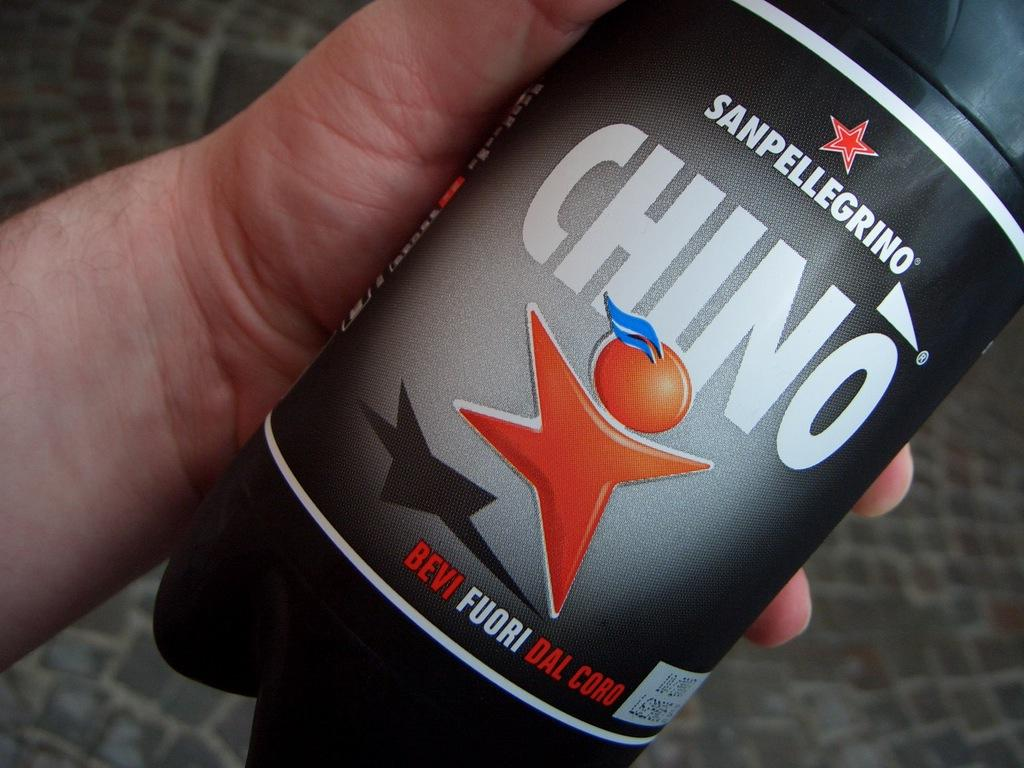<image>
Relay a brief, clear account of the picture shown. A bottle of a drink called Sanpellegrino Chino. 